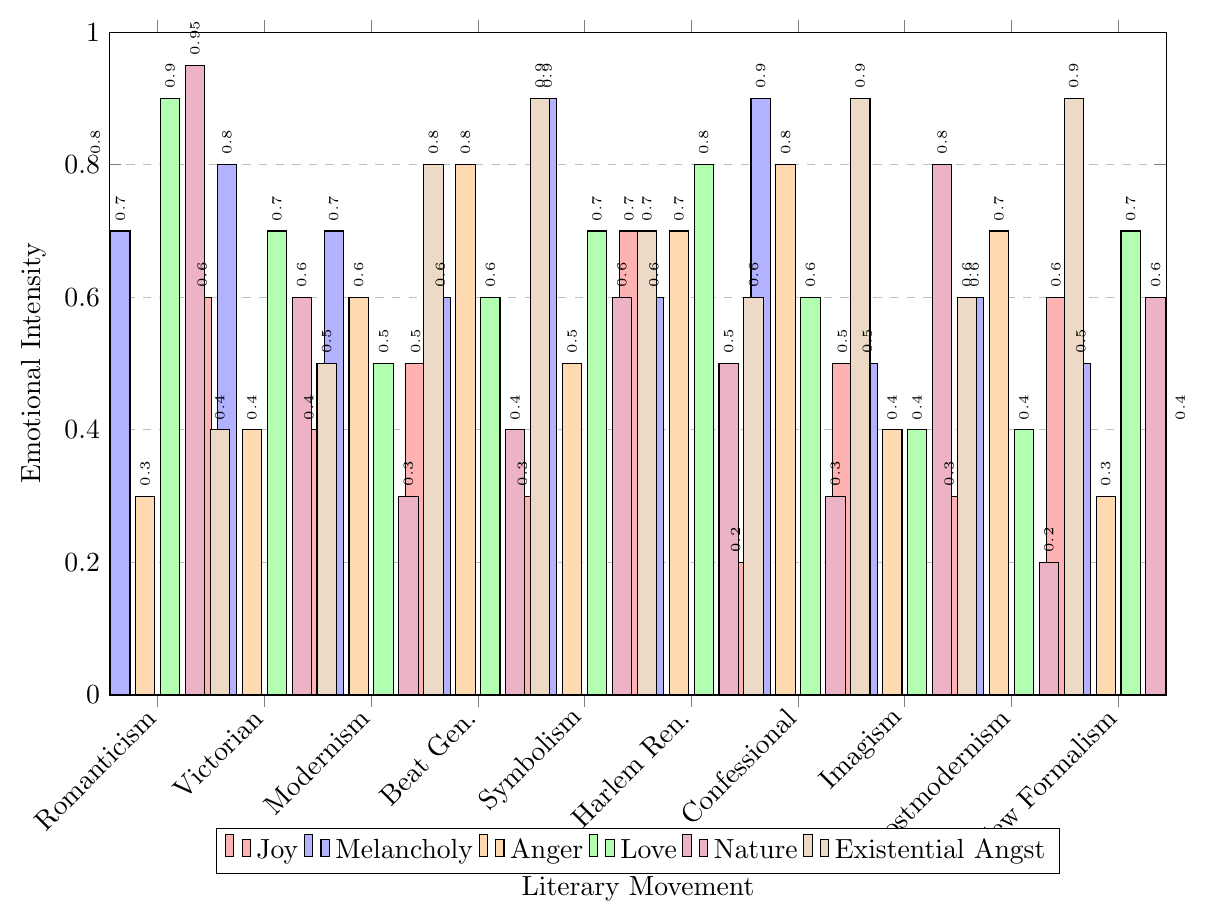Which literary movement shows the highest emotional intensity for 'Nature'? To find the highest emotional intensity for 'Nature', identify the tallest bar in the purple shade. The tallest bar for 'Nature' corresponds to Romanticism with a value of 0.95.
Answer: Romanticism Compare the levels of 'Joy' and 'Love' in the Modernism movement. Which is higher? Identify the bars corresponding to 'Joy' and 'Love' for Modernism. The height of the 'Joy' bar is 0.4, and the 'Love' bar is 0.5. The 'Love' bar is higher than the 'Joy' bar.
Answer: 'Love' is higher Which emotion has the lowest intensity in the Symbolism movement? For Symbolism, observe the heights of the bars. Identify the shortest bar, which corresponds to 'Joy' with an intensity of 0.3.
Answer: 'Joy' What is the sum of 'Melancholy' and 'Anger' in the Confessional Poetry movement? sum the values of 'Melancholy' (0.9) and 'Anger' (0.8) in Confessional Poetry. 0.9 + 0.8 equals 1.7.
Answer: 1.7 Which literary movement has equal values for both 'Joy' and 'Existential Angst'? Compare the 'Joy' and 'Existential Angst' bars for each movement. 'Imagism' is the only movement with both values at 0.5 and 0.6, respectively. No exact match is found.
Answer: No exact match How does the 'Existential Angst' level in Postmodernism compare to that in Harlem Renaissance? Compare the heights of the 'Existential Angst' bars. Postmodernism's level is 0.9, and Harlem Renaissance's level is 0.6. Postmodernism has a higher level.
Answer: Postmodernism is higher What is the average intensity of 'Melancholy' across all movements? Sum the 'Melancholy' intensities and divide by the number of movements. (0.7 + 0.8 + 0.7 + 0.6 + 0.9 + 0.6 + 0.9 + 0.5 + 0.6 + 0.5) equals 7.8. Divide 7.8 by 10.
Answer: 0.78 Which literary movement has the greatest difference between 'Joy' and 'Melancholy'? Calculate the differences for each movement. Romanticism: 0.1, Victorian: 0.2, Modernism: 0.3, Beat: 0.1, Symbolism: 0.6, Harlem: 0.1, Confessional: 0.7, Imagism: 0, Postmodernism: 0.3, New Formalism: 0.1. The greatest difference is in Confessional Poetry with 0.7.
Answer: Confessional Poetry What is the median value of 'Anger' across all movements? Arrange the 'Anger' values (0.3, 0.3, 0.4, 0.4, 0.5, 0.6, 0.7, 0.7, 0.8, 0.8). The median is the average of the 5th and 6th values (0.5 + 0.6) / 2 = 0.55.
Answer: 0.55 